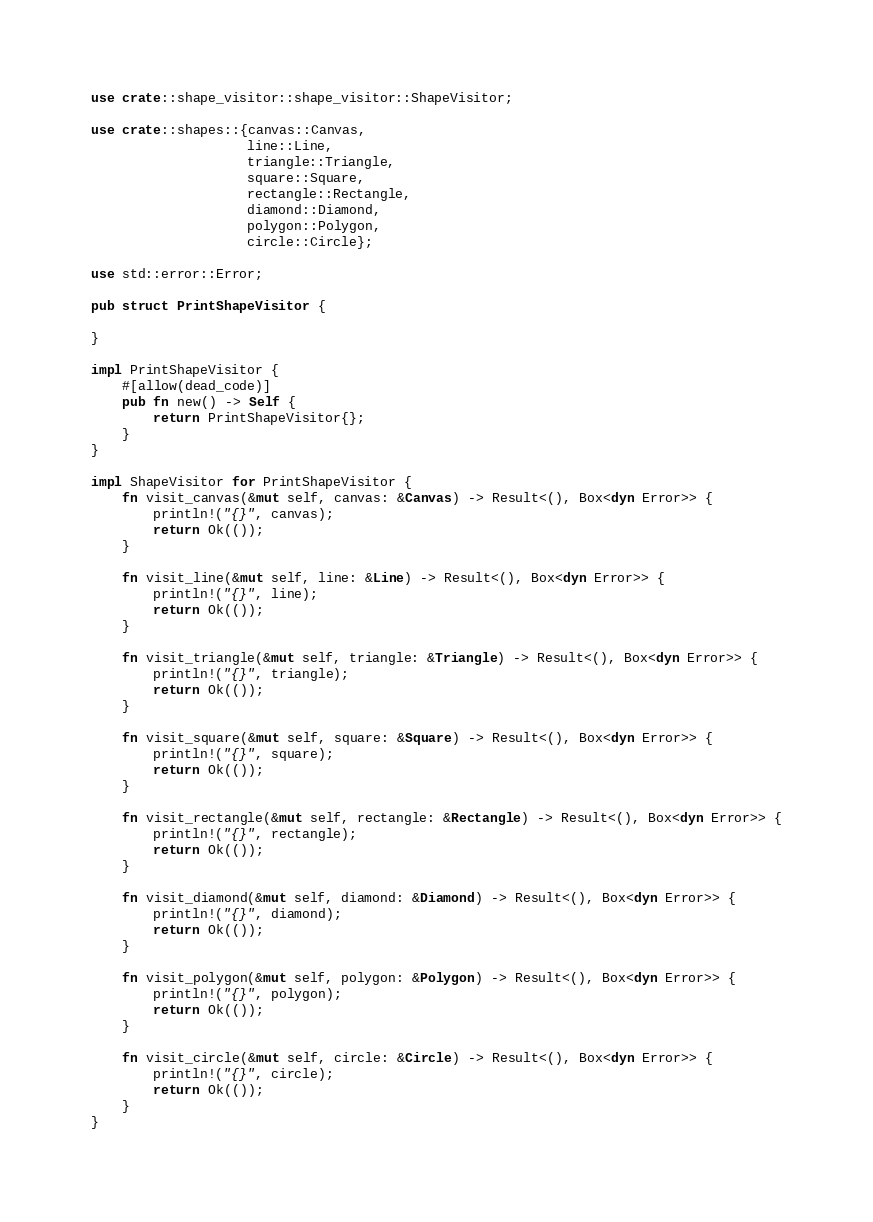Convert code to text. <code><loc_0><loc_0><loc_500><loc_500><_Rust_>
use crate::shape_visitor::shape_visitor::ShapeVisitor;

use crate::shapes::{canvas::Canvas,
                    line::Line,
                    triangle::Triangle,
                    square::Square,
                    rectangle::Rectangle,
                    diamond::Diamond,
                    polygon::Polygon,
                    circle::Circle};

use std::error::Error;

pub struct PrintShapeVisitor {

}

impl PrintShapeVisitor {
    #[allow(dead_code)]
    pub fn new() -> Self {
        return PrintShapeVisitor{};
    }
}

impl ShapeVisitor for PrintShapeVisitor {
    fn visit_canvas(&mut self, canvas: &Canvas) -> Result<(), Box<dyn Error>> {
        println!("{}", canvas);
        return Ok(());
    }

    fn visit_line(&mut self, line: &Line) -> Result<(), Box<dyn Error>> {
        println!("{}", line);
        return Ok(());
    }

    fn visit_triangle(&mut self, triangle: &Triangle) -> Result<(), Box<dyn Error>> {
        println!("{}", triangle);
        return Ok(());
    }

    fn visit_square(&mut self, square: &Square) -> Result<(), Box<dyn Error>> {
        println!("{}", square);
        return Ok(());
    }

    fn visit_rectangle(&mut self, rectangle: &Rectangle) -> Result<(), Box<dyn Error>> {
        println!("{}", rectangle);
        return Ok(());
    }

    fn visit_diamond(&mut self, diamond: &Diamond) -> Result<(), Box<dyn Error>> {
        println!("{}", diamond);
        return Ok(());
    }

    fn visit_polygon(&mut self, polygon: &Polygon) -> Result<(), Box<dyn Error>> {
        println!("{}", polygon);
        return Ok(());
    }

    fn visit_circle(&mut self, circle: &Circle) -> Result<(), Box<dyn Error>> {
        println!("{}", circle);
        return Ok(());
    }
}
</code> 